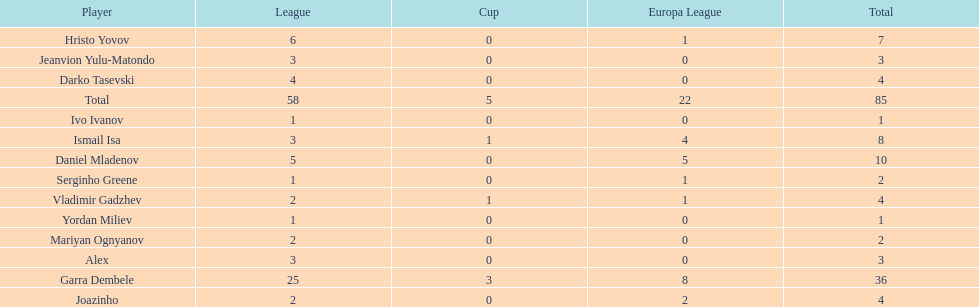Which players only scored one goal? Serginho Greene, Yordan Miliev, Ivo Ivanov. Parse the table in full. {'header': ['Player', 'League', 'Cup', 'Europa League', 'Total'], 'rows': [['Hristo Yovov', '6', '0', '1', '7'], ['Jeanvion Yulu-Matondo', '3', '0', '0', '3'], ['Darko Tasevski', '4', '0', '0', '4'], ['Total', '58', '5', '22', '85'], ['Ivo Ivanov', '1', '0', '0', '1'], ['Ismail Isa', '3', '1', '4', '8'], ['Daniel Mladenov', '5', '0', '5', '10'], ['Serginho Greene', '1', '0', '1', '2'], ['Vladimir Gadzhev', '2', '1', '1', '4'], ['Yordan Miliev', '1', '0', '0', '1'], ['Mariyan Ognyanov', '2', '0', '0', '2'], ['Alex', '3', '0', '0', '3'], ['Garra Dembele', '25', '3', '8', '36'], ['Joazinho', '2', '0', '2', '4']]} 